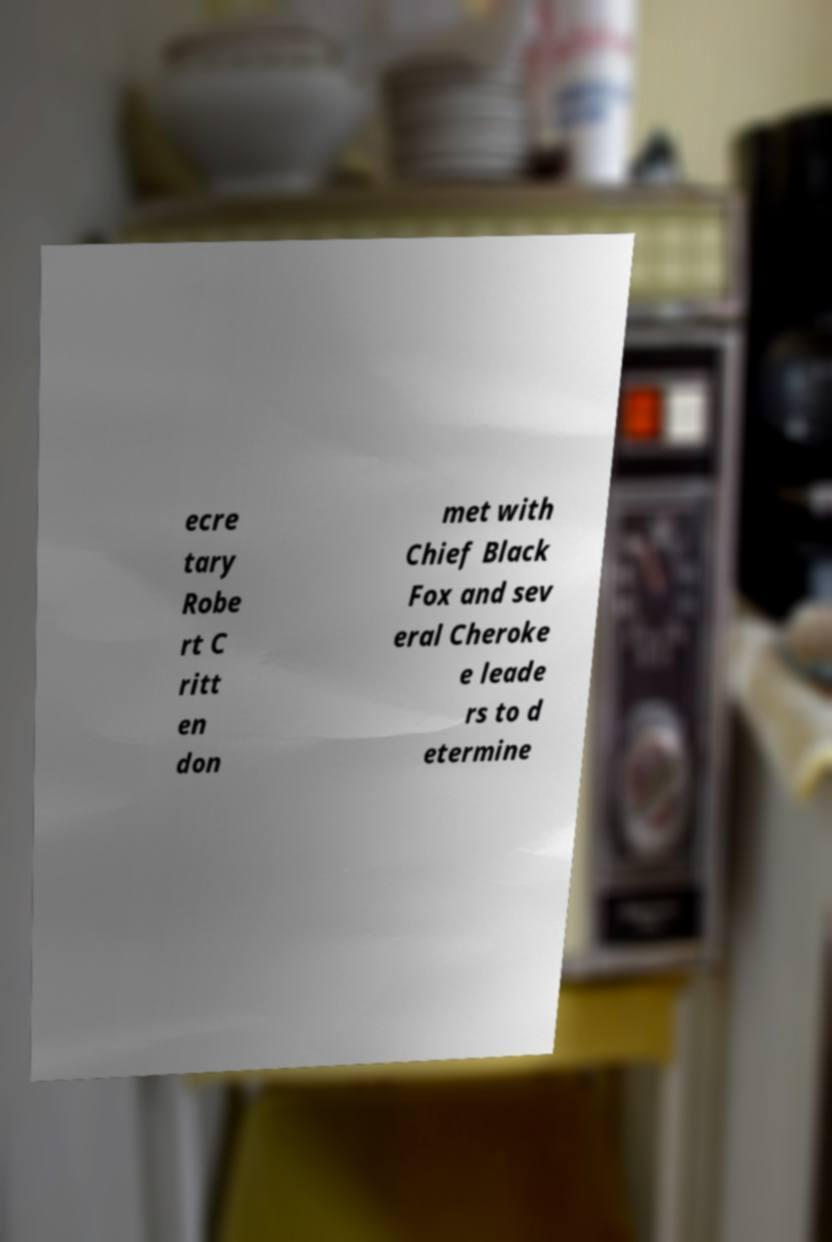What messages or text are displayed in this image? I need them in a readable, typed format. ecre tary Robe rt C ritt en don met with Chief Black Fox and sev eral Cheroke e leade rs to d etermine 